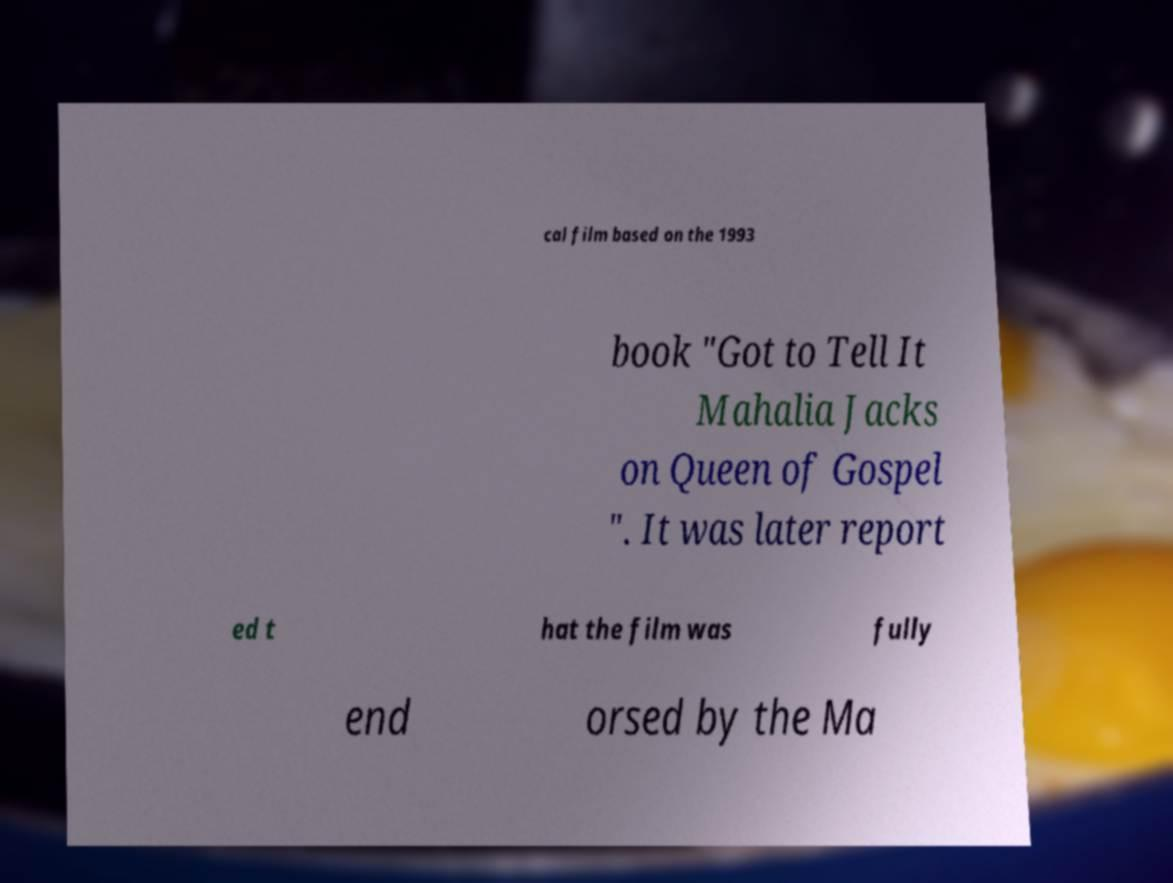I need the written content from this picture converted into text. Can you do that? cal film based on the 1993 book "Got to Tell It Mahalia Jacks on Queen of Gospel ". It was later report ed t hat the film was fully end orsed by the Ma 